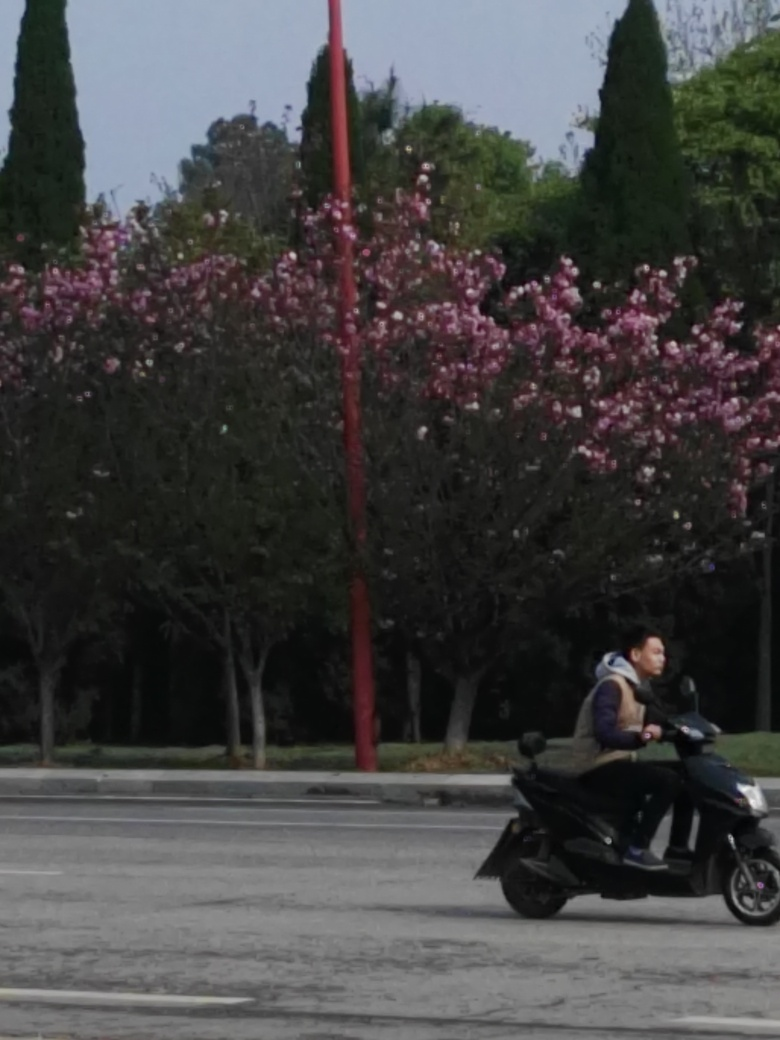What might the weather be like in this photo? The overall lighting and absence of shadows suggest that the weather is overcast with a cloudy sky, which diffuses the sunlight and softens shadows. The attire of the individual on the motor scooter, which includes a jacket, hints at cool or mild temperatures, appropriate for spring weather. 